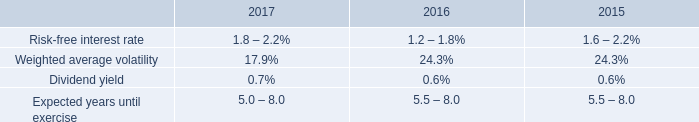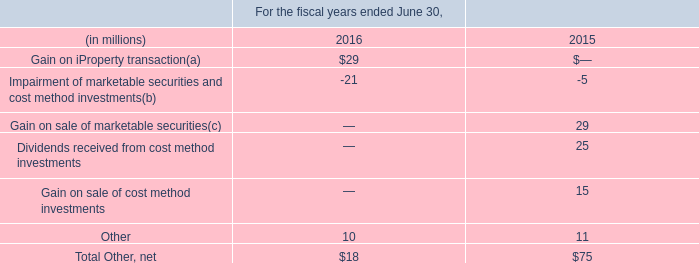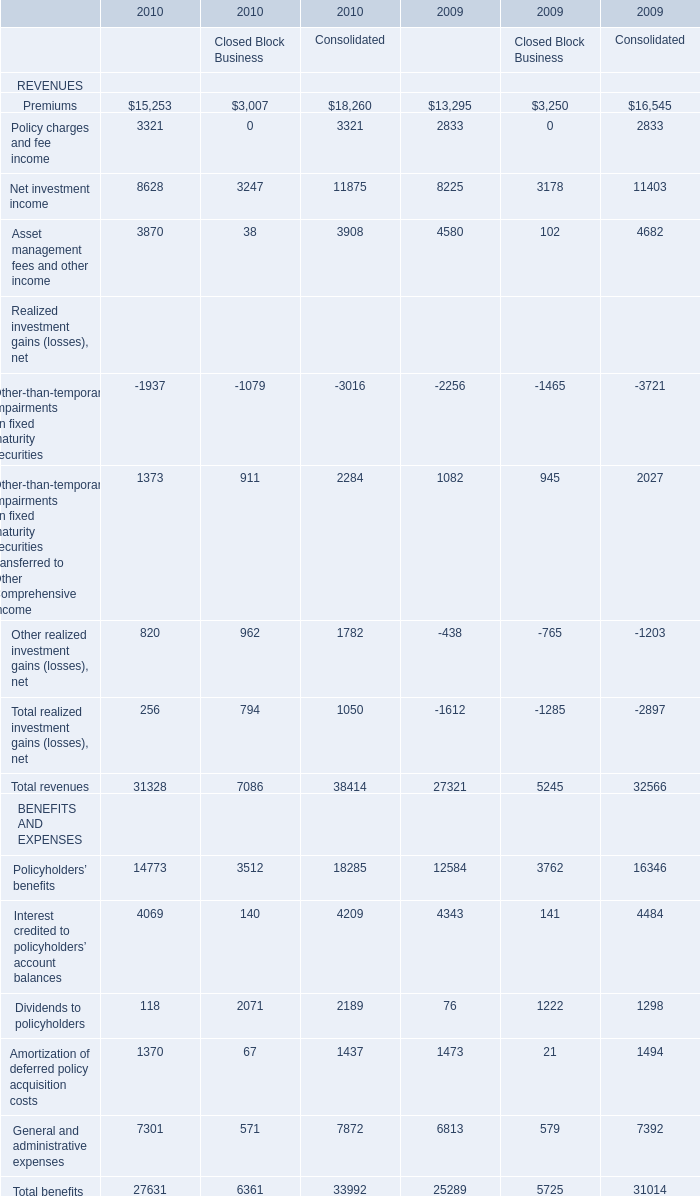Which Revenues for Closed Block Business has the second largest number in 2010? 
Answer: premiums. 